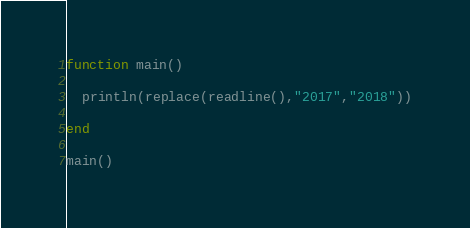<code> <loc_0><loc_0><loc_500><loc_500><_Julia_>function main()
  
  println(replace(readline(),"2017","2018"))
  
end

main()</code> 